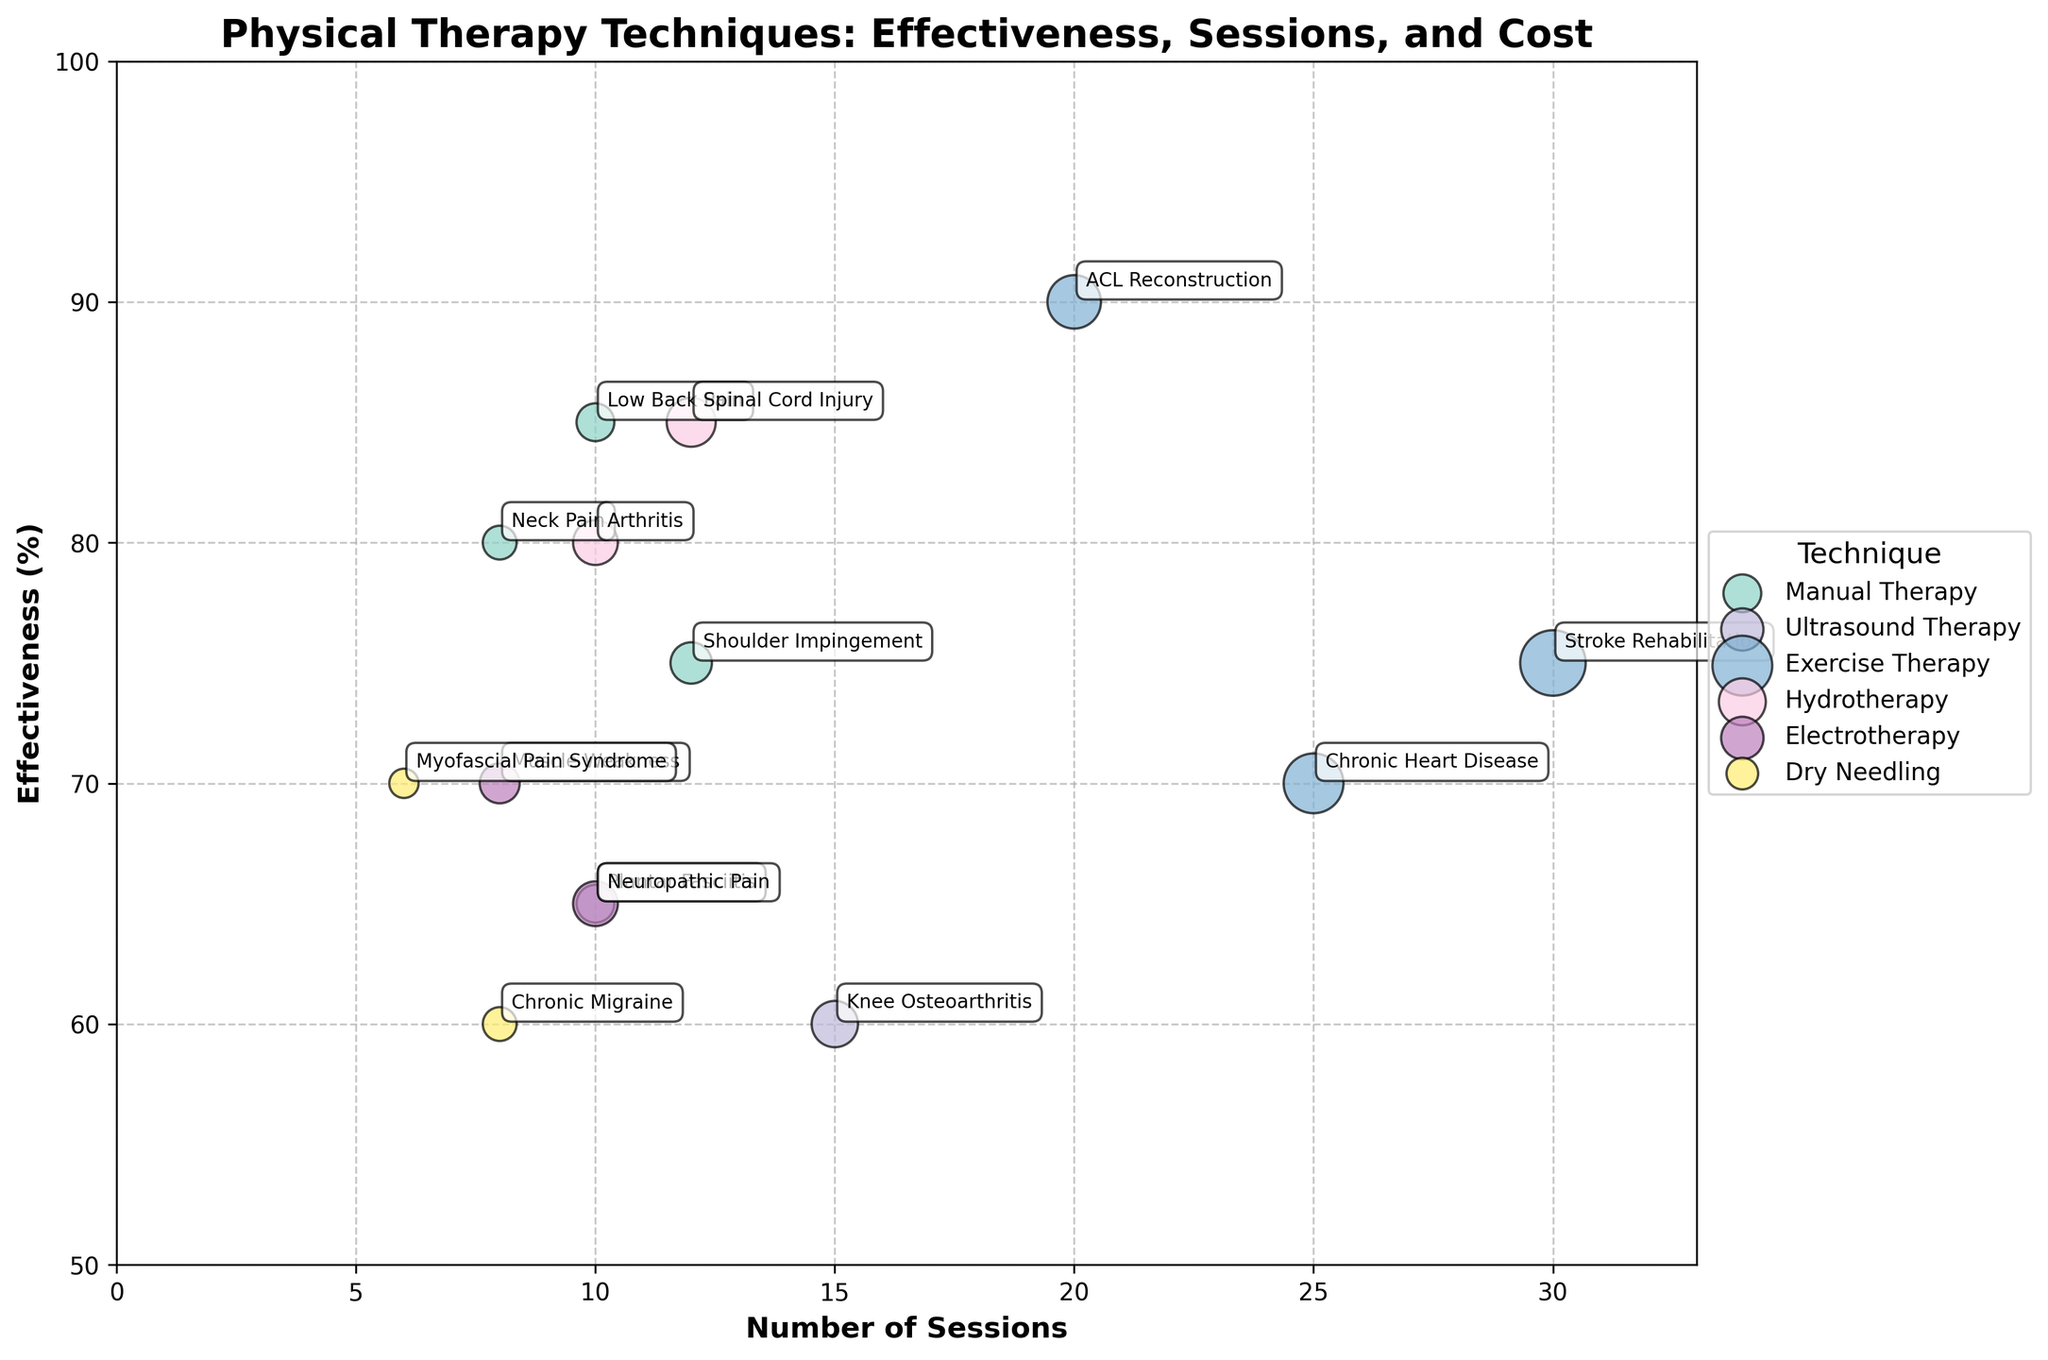What is the highest effectiveness percentage for Manual Therapy? The highest effectiveness percentage for Manual Therapy is found by looking at the bubbles labeled with Manual Therapy. The highest value among them is 85% for Low Back Pain.
Answer: 85% Which therapy technique has the highest effectiveness for Stroke Rehabilitation? To find this, locate the bubble labeled "Stroke Rehabilitation" and identify its associated technique, which is Exercise Therapy with an effectiveness of 75%.
Answer: Exercise Therapy How many sessions are required for Electrotherapy to treat Neuropathic Pain? Find the bubble labeled "Neuropathic Pain" and check the number of sessions required, which is 10.
Answer: 10 Which condition treated with Manual Therapy has the lowest effectiveness? Among the conditions treated with Manual Therapy, find the lowest effectiveness percentage. The conditions are Low Back Pain (85%), Neck Pain (80%), and Shoulder Impingement (75%), with Shoulder Impingement being the lowest.
Answer: Shoulder Impingement What is the range of effectiveness percentages for Exercise Therapy across different conditions? Find the highest and lowest effectiveness percentages for Exercise Therapy across all conditions. The highest is for ACL Reconstruction (90%) and the lowest is for Chronic Heart Disease (70%), giving a range of 90% - 70% = 20%.
Answer: 20% Which therapy technique requires the maximum number of sessions, and what is the condition treated? Identify the bubble with the maximum number of sessions, which is 30 sessions for Exercise Therapy treating Stroke Rehabilitation.
Answer: Exercise Therapy, Stroke Rehabilitation For Hydrotherapy, which condition has the higher effectiveness percentage: Arthritis or Spinal Cord Injury? Compare the effectiveness percentages for Hydrotherapy treating Arthritis (80%) and Spinal Cord Injury (85%). Spinal Cord Injury has a higher percentage.
Answer: Spinal Cord Injury Does Dry Needling have at least one condition with an effectiveness of 70% or more? Check the effectiveness percentages for Dry Needling. It treats Myofascial Pain Syndrome (70%) and Chronic Migraine (60%). Myofascial Pain Syndrome has 70%, hence fulfilling the criterion.
Answer: Yes Which condition has the highest cost associated with its therapy, and what is the therapy technique? Find the bubble with the largest size indicating the highest cost. The largest bubble is for Stroke Rehabilitation with Exercise Therapy, costing 1500.
Answer: Stroke Rehabilitation, Exercise Therapy What is the average effectiveness percentage across all conditions treated by Ultrasound Therapy? To find this, average the effectiveness percentages for Ultrasound Therapy: (60% for Knee Osteoarthritis + 65% for Plantar Fasciitis) / 2 = 62.5%.
Answer: 62.5% 